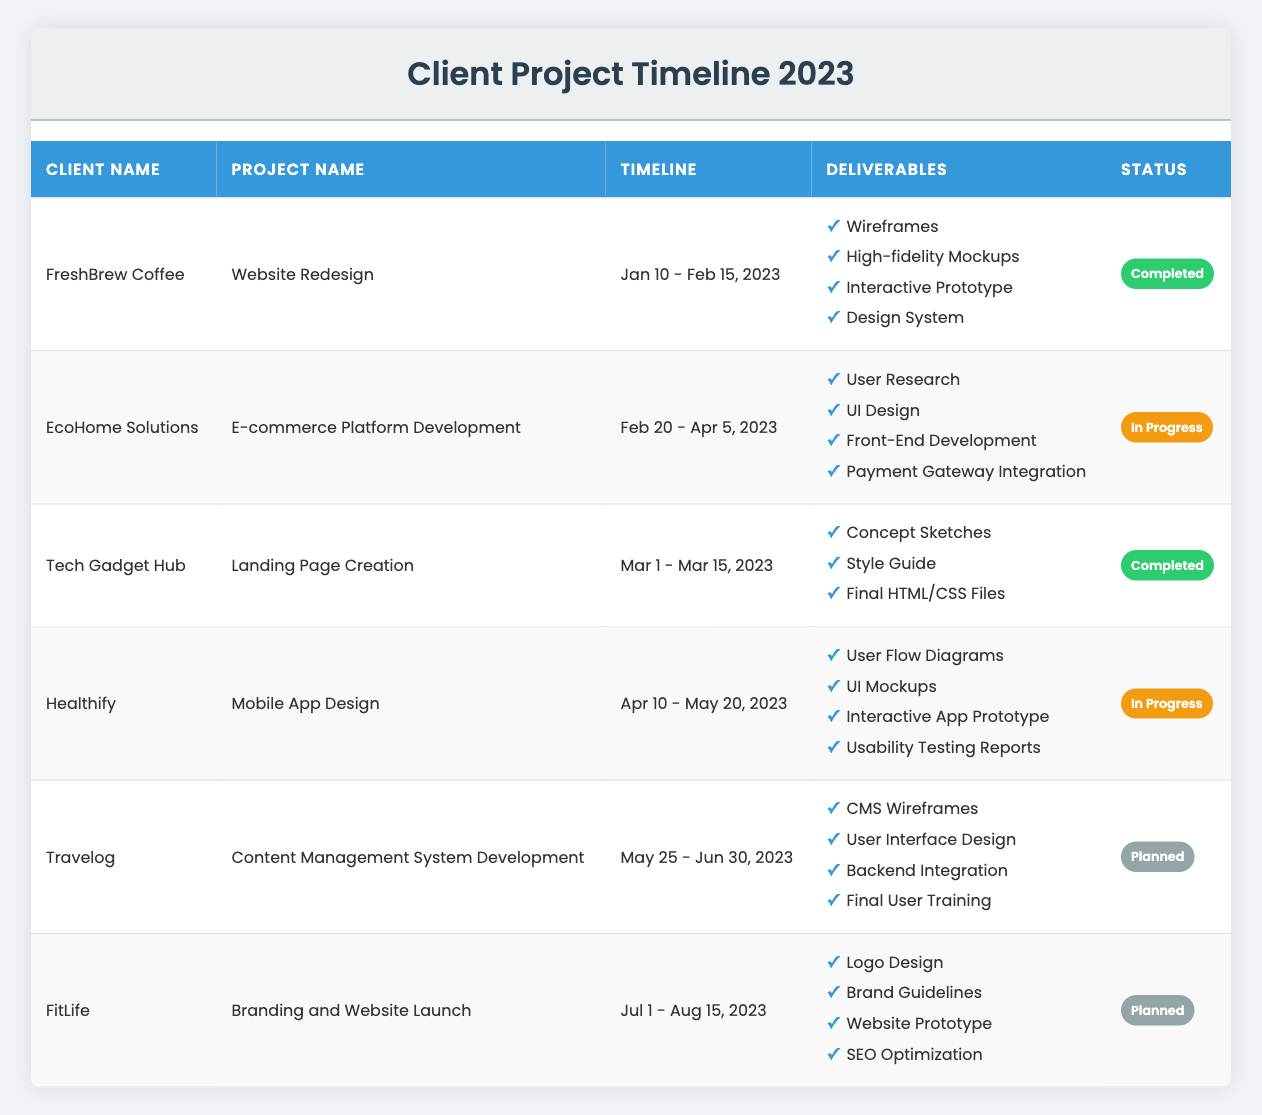What is the project status for EcoHome Solutions? The table indicates that the project status for EcoHome Solutions is listed under the status column, where it states "In Progress."
Answer: In Progress How many deliverables are listed for the project with Tech Gadget Hub? The Tech Gadget Hub project has three deliverables listed: Concept Sketches, Style Guide, and Final HTML/CSS Files, which are detailed in the deliverables column.
Answer: 3 Which client has a project that is planned to start after August? The table lists two clients with planned projects: Travelog (starting on May 25) and FitLife (starting on July 1). FitLife is the only project that starts after August, which means there are no projects planned to start after August. Therefore, the answer is none.
Answer: None How many clients have their project status marked as completed? In the status column, two clients are marked as completed: FreshBrew Coffee and Tech Gadget Hub. Counting these, we find that there are two completed projects.
Answer: 2 Which project deliverable is shared between the project of EcoHome Solutions and Healthify? To find a shared deliverable, we look at both projects' deliverables. EcoHome Solutions has User Research, UI Design, Front-End Development, and Payment Gateway Integration while Healthify includes User Flow Diagrams, UI Mockups, Interactive App Prototype, and Usability Testing Reports. The common deliverable between both is "UI Design."
Answer: UI Design What is the duration (in days) of the project for Healthify? The start date for Healthify is April 10, and the end date is May 20. To calculate the duration, subtract the start date from the end date. April has 30 days, so the duration is (20 - 10 + 30) = 40 days (from 10th April to 20th May).
Answer: 40 days Are all deliverables for the project of FreshBrew Coffee completed? The project status for FreshBrew Coffee shows "Completed" in the status column, which indicates that all listed deliverables (Wireframes, High-fidelity Mockups, Interactive Prototype, Design System) have been successfully completed. Thus, the answer is yes.
Answer: Yes If all projects in the table have their estimated ending times met, when will the last project end? The last project in the timeline is for FitLife, which ends on August 15. Looking at the table reveals this ending date. Since it is the latest among all projects listed, it should be the answer.
Answer: August 15 